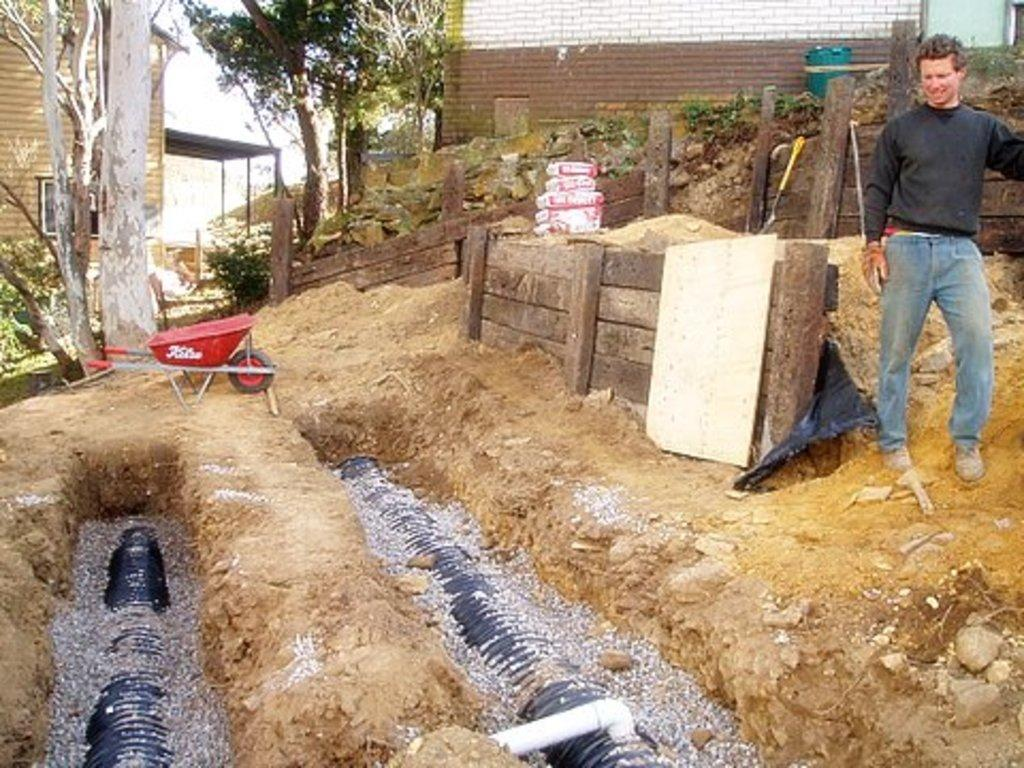What is the person in the image doing? The person is standing on the ground in the image. What can be seen beneath the ground in the image? There are pipe lines in the earth in the image. What type of structures are visible in the image? There are houses visible in the image. What type of vegetation is present in the image? There are trees in the image. What type of furniture is present in the image? There are wooden tables in the image. What type of objects are present in the image? There are boxes in the image. Can you tell me how many trees the person is biting in the image? There is no indication that the person is biting any trees in the image. 